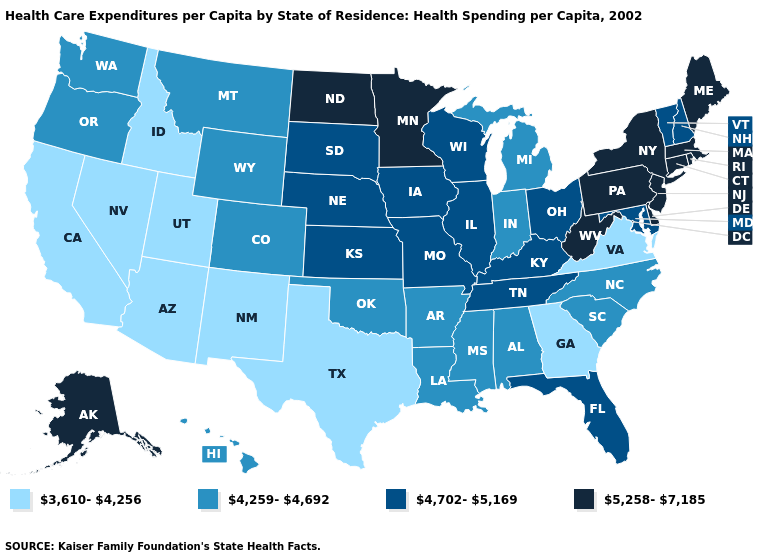Name the states that have a value in the range 3,610-4,256?
Short answer required. Arizona, California, Georgia, Idaho, Nevada, New Mexico, Texas, Utah, Virginia. Among the states that border New Mexico , which have the highest value?
Answer briefly. Colorado, Oklahoma. How many symbols are there in the legend?
Keep it brief. 4. Name the states that have a value in the range 3,610-4,256?
Answer briefly. Arizona, California, Georgia, Idaho, Nevada, New Mexico, Texas, Utah, Virginia. Which states have the lowest value in the West?
Short answer required. Arizona, California, Idaho, Nevada, New Mexico, Utah. What is the lowest value in the USA?
Keep it brief. 3,610-4,256. How many symbols are there in the legend?
Short answer required. 4. Name the states that have a value in the range 5,258-7,185?
Write a very short answer. Alaska, Connecticut, Delaware, Maine, Massachusetts, Minnesota, New Jersey, New York, North Dakota, Pennsylvania, Rhode Island, West Virginia. What is the value of Georgia?
Short answer required. 3,610-4,256. How many symbols are there in the legend?
Short answer required. 4. Name the states that have a value in the range 5,258-7,185?
Short answer required. Alaska, Connecticut, Delaware, Maine, Massachusetts, Minnesota, New Jersey, New York, North Dakota, Pennsylvania, Rhode Island, West Virginia. Name the states that have a value in the range 5,258-7,185?
Short answer required. Alaska, Connecticut, Delaware, Maine, Massachusetts, Minnesota, New Jersey, New York, North Dakota, Pennsylvania, Rhode Island, West Virginia. How many symbols are there in the legend?
Quick response, please. 4. Name the states that have a value in the range 3,610-4,256?
Keep it brief. Arizona, California, Georgia, Idaho, Nevada, New Mexico, Texas, Utah, Virginia. What is the value of Montana?
Concise answer only. 4,259-4,692. 